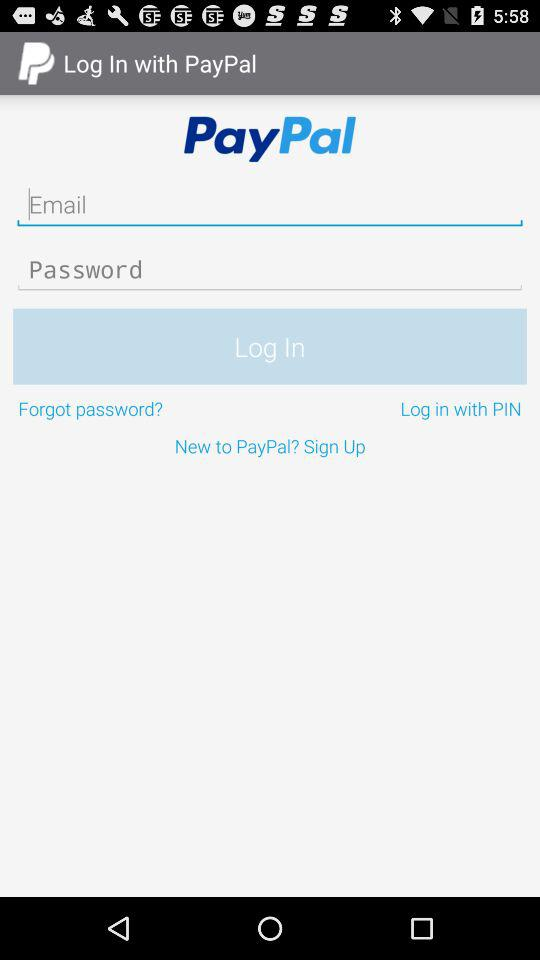How can we login? You can login "with PIN". 